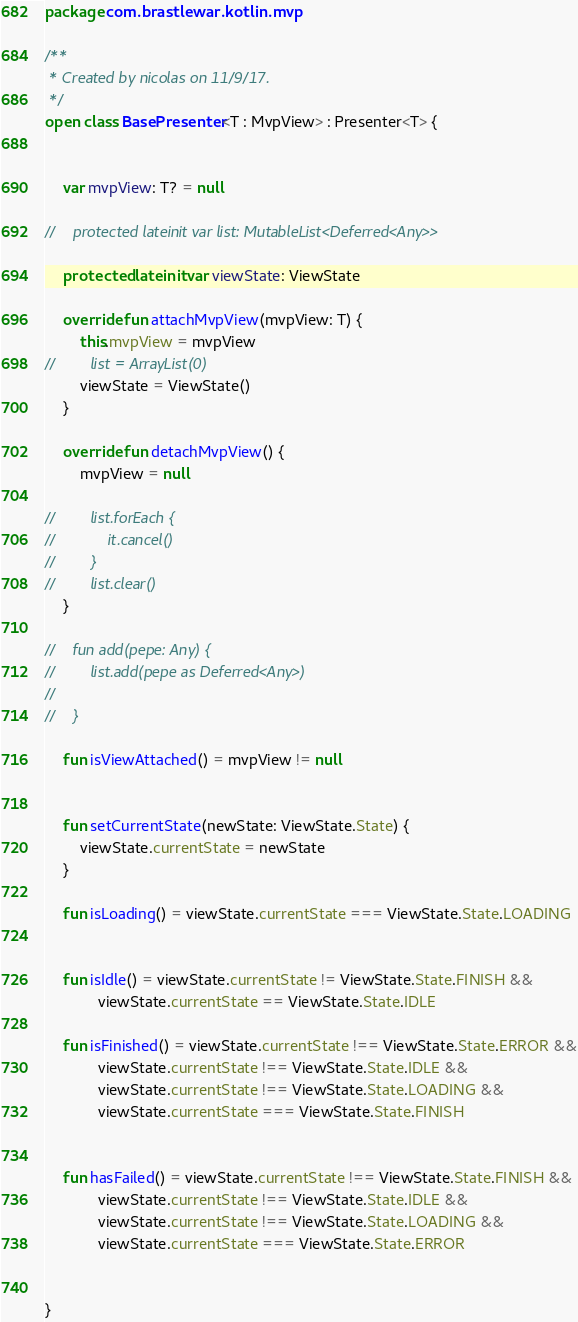Convert code to text. <code><loc_0><loc_0><loc_500><loc_500><_Kotlin_>package com.brastlewar.kotlin.mvp

/**
 * Created by nicolas on 11/9/17.
 */
open class BasePresenter<T : MvpView> : Presenter<T> {


    var mvpView: T? = null

//    protected lateinit var list: MutableList<Deferred<Any>>

    protected lateinit var viewState: ViewState

    override fun attachMvpView(mvpView: T) {
        this.mvpView = mvpView
//        list = ArrayList(0)
        viewState = ViewState()
    }

    override fun detachMvpView() {
        mvpView = null

//        list.forEach {
//            it.cancel()
//        }
//        list.clear()
    }

//    fun add(pepe: Any) {
//        list.add(pepe as Deferred<Any>)
//
//    }

    fun isViewAttached() = mvpView != null


    fun setCurrentState(newState: ViewState.State) {
        viewState.currentState = newState
    }

    fun isLoading() = viewState.currentState === ViewState.State.LOADING


    fun isIdle() = viewState.currentState != ViewState.State.FINISH &&
            viewState.currentState == ViewState.State.IDLE

    fun isFinished() = viewState.currentState !== ViewState.State.ERROR &&
            viewState.currentState !== ViewState.State.IDLE &&
            viewState.currentState !== ViewState.State.LOADING &&
            viewState.currentState === ViewState.State.FINISH


    fun hasFailed() = viewState.currentState !== ViewState.State.FINISH &&
            viewState.currentState !== ViewState.State.IDLE &&
            viewState.currentState !== ViewState.State.LOADING &&
            viewState.currentState === ViewState.State.ERROR


}</code> 